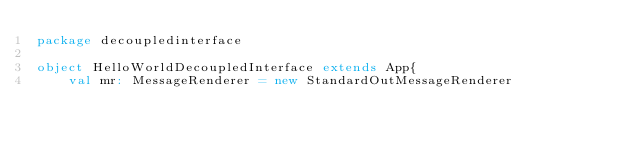Convert code to text. <code><loc_0><loc_0><loc_500><loc_500><_Scala_>package decoupledinterface

object HelloWorldDecoupledInterface extends App{
    val mr: MessageRenderer = new StandardOutMessageRenderer</code> 